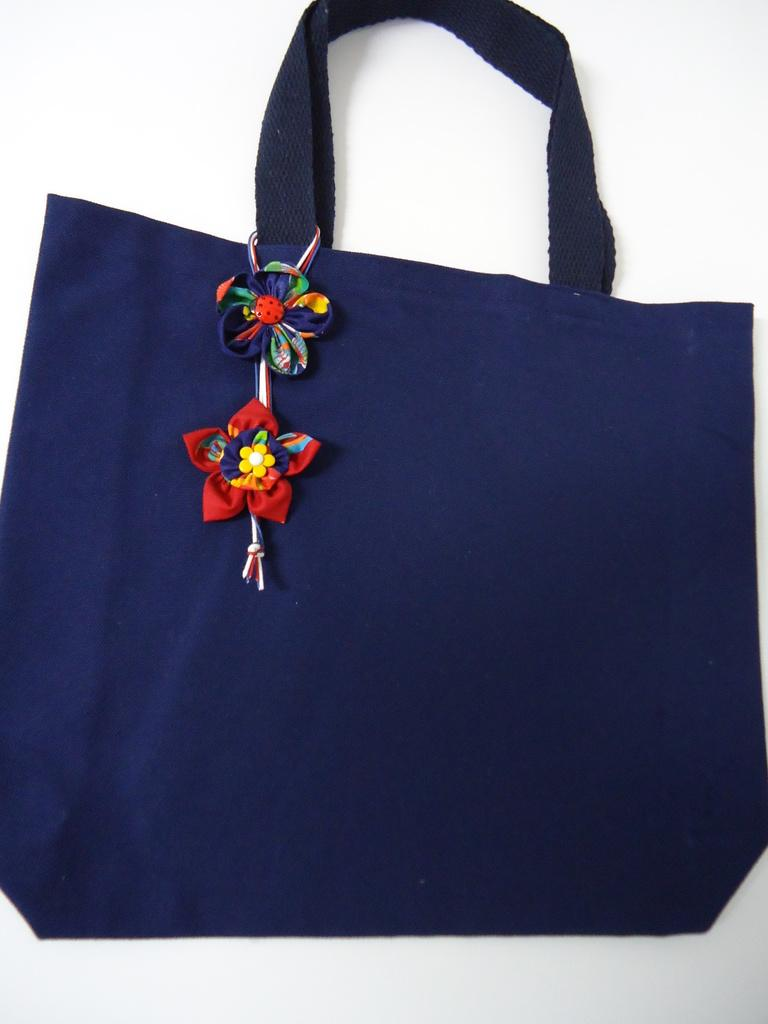What color is the bag in the image? The bag in the image is blue. Are there any designs or patterns on the bag? Yes, the bag has two flowers on it. Where is the bag located in the image? The bag is hanging on a white color wall. Can you see any actions being performed by the fang in the image? There is no fang present in the image. Is there a chessboard visible in the image? No, there is no chessboard present in the image. 